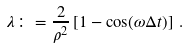Convert formula to latex. <formula><loc_0><loc_0><loc_500><loc_500>\lambda \colon = \frac { 2 } { \rho ^ { 2 } } \left [ 1 - \cos ( \omega \Delta t ) \right ] \, .</formula> 